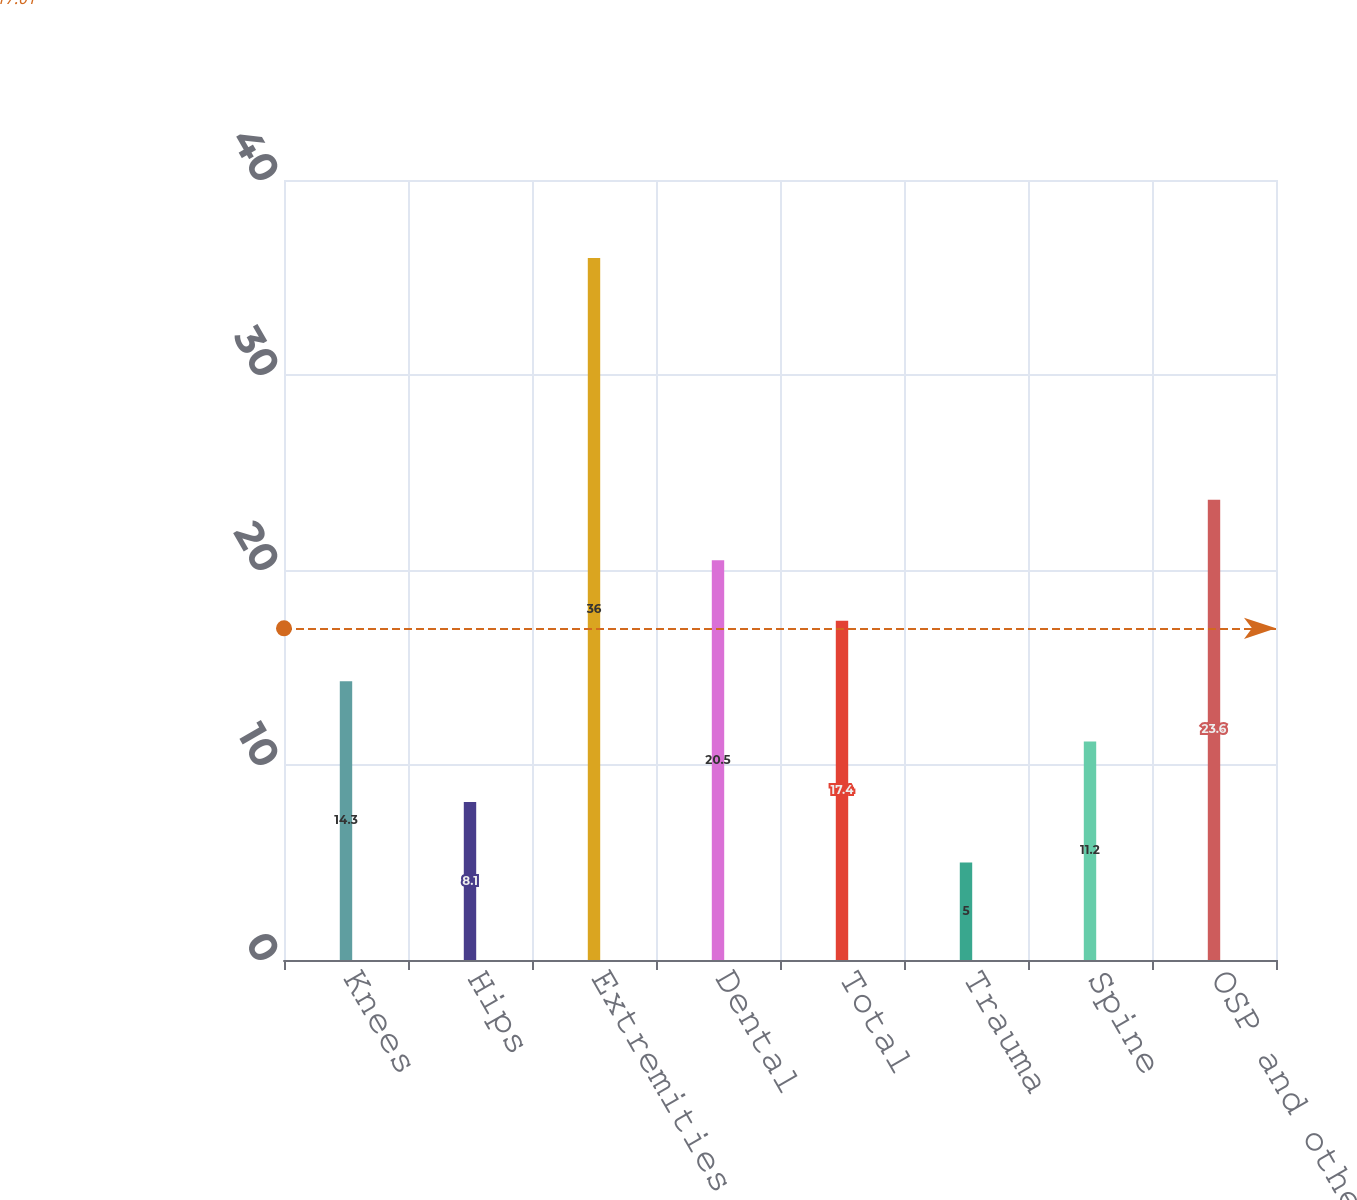<chart> <loc_0><loc_0><loc_500><loc_500><bar_chart><fcel>Knees<fcel>Hips<fcel>Extremities<fcel>Dental<fcel>Total<fcel>Trauma<fcel>Spine<fcel>OSP and other<nl><fcel>14.3<fcel>8.1<fcel>36<fcel>20.5<fcel>17.4<fcel>5<fcel>11.2<fcel>23.6<nl></chart> 